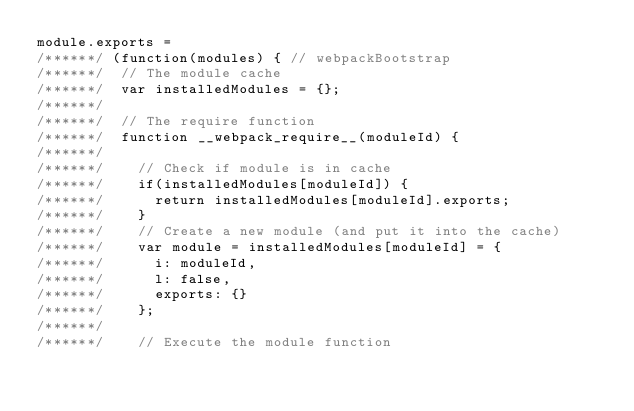Convert code to text. <code><loc_0><loc_0><loc_500><loc_500><_JavaScript_>module.exports =
/******/ (function(modules) { // webpackBootstrap
/******/ 	// The module cache
/******/ 	var installedModules = {};
/******/
/******/ 	// The require function
/******/ 	function __webpack_require__(moduleId) {
/******/
/******/ 		// Check if module is in cache
/******/ 		if(installedModules[moduleId]) {
/******/ 			return installedModules[moduleId].exports;
/******/ 		}
/******/ 		// Create a new module (and put it into the cache)
/******/ 		var module = installedModules[moduleId] = {
/******/ 			i: moduleId,
/******/ 			l: false,
/******/ 			exports: {}
/******/ 		};
/******/
/******/ 		// Execute the module function</code> 